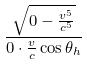Convert formula to latex. <formula><loc_0><loc_0><loc_500><loc_500>\frac { \sqrt { 0 - \frac { v ^ { 5 } } { c ^ { 5 } } } } { 0 \cdot \frac { v } { c } \cos \theta _ { h } }</formula> 